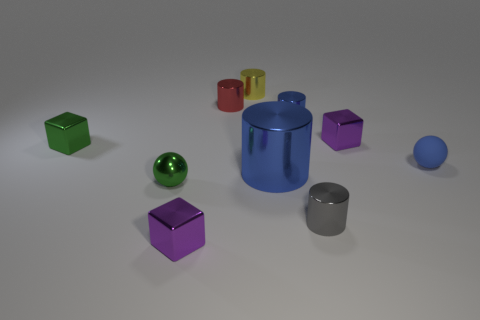Reflect on the composition of shapes and colors in this image. This image presents a striking composition of geometric shapes, where the vibrant colors draw attention to the variety of forms. We have cylinders, cubes, and spheres, each contributing to a harmonious yet dynamic arrangement. The color palette is quite diverse, featuring greens, reds, yellows, purples, and blues, against an understated grey background—creating a modernistic still life tableau. 